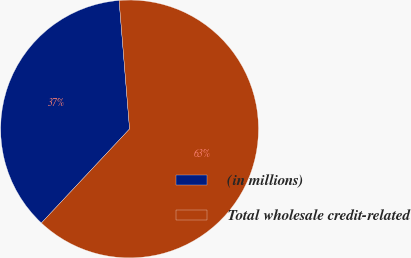<chart> <loc_0><loc_0><loc_500><loc_500><pie_chart><fcel>(in millions)<fcel>Total wholesale credit-related<nl><fcel>36.72%<fcel>63.28%<nl></chart> 